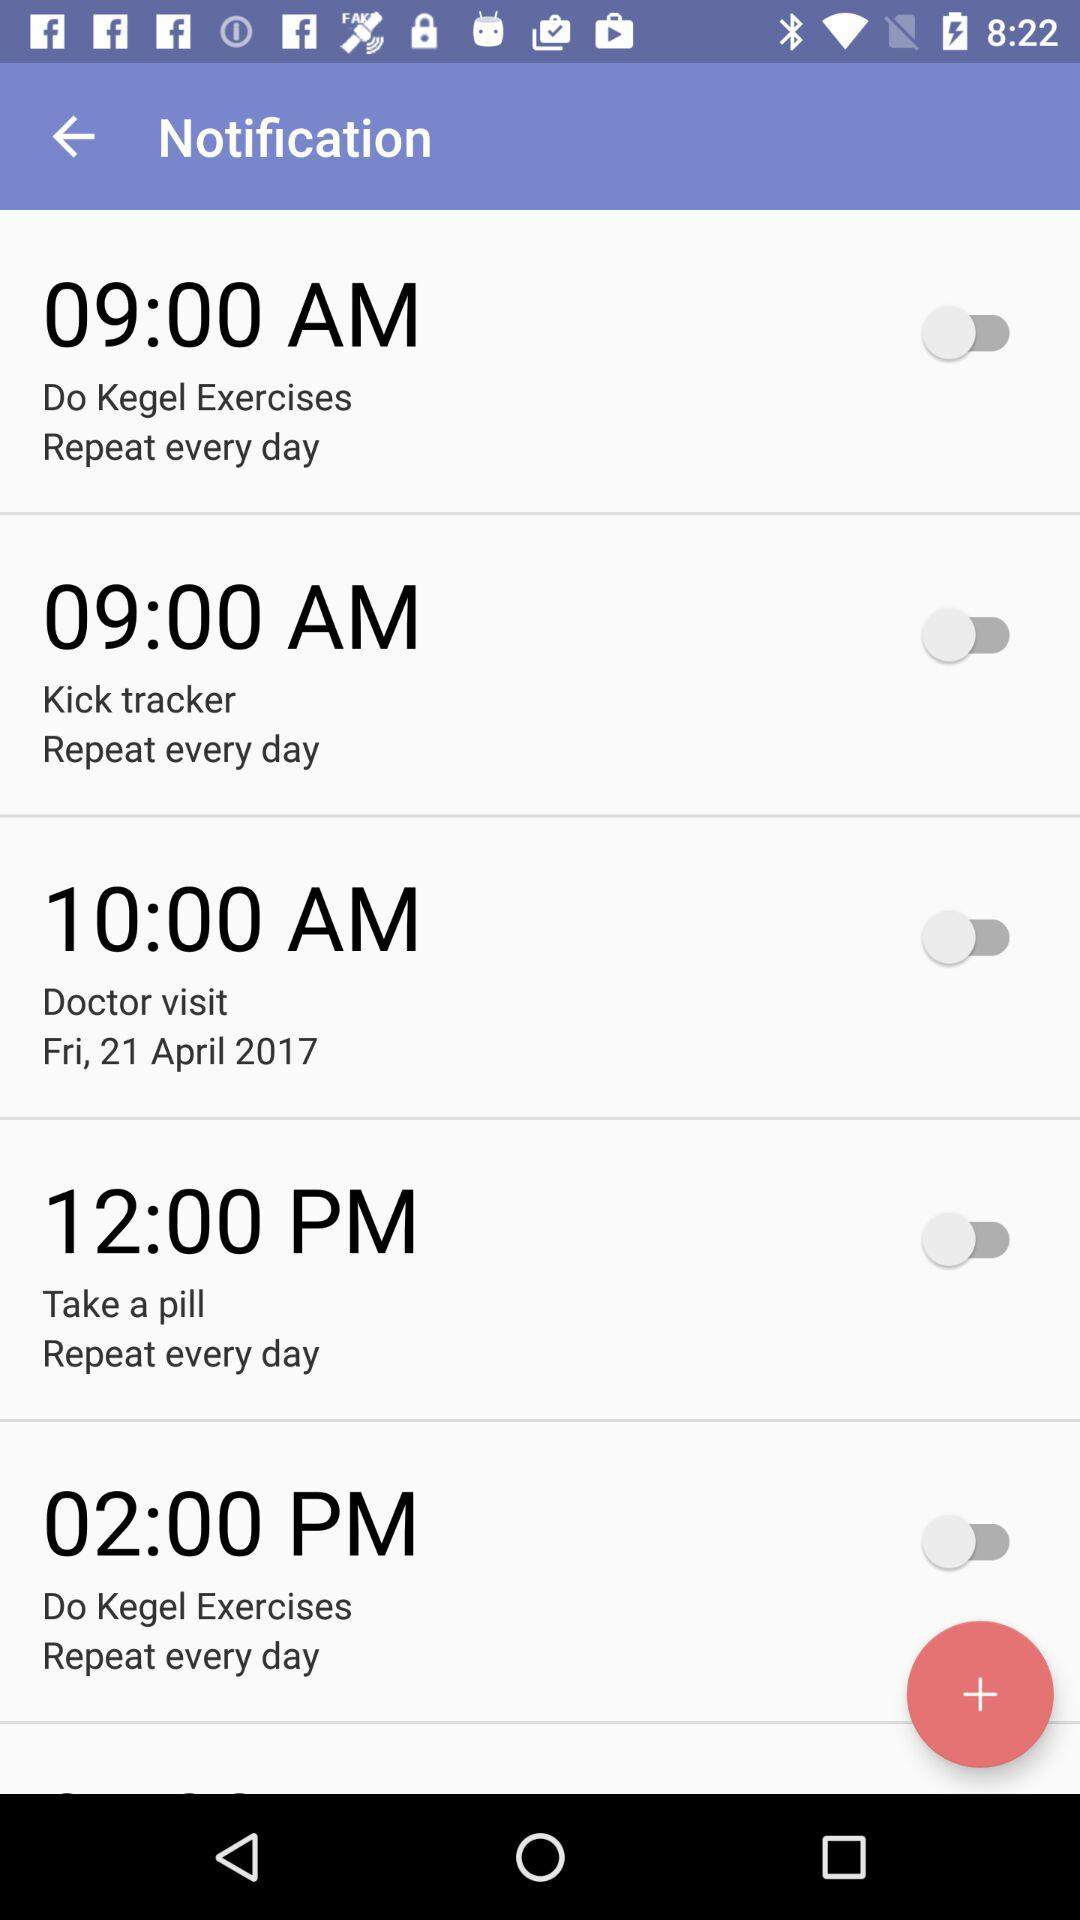How many reminders are there?
Answer the question using a single word or phrase. 5 